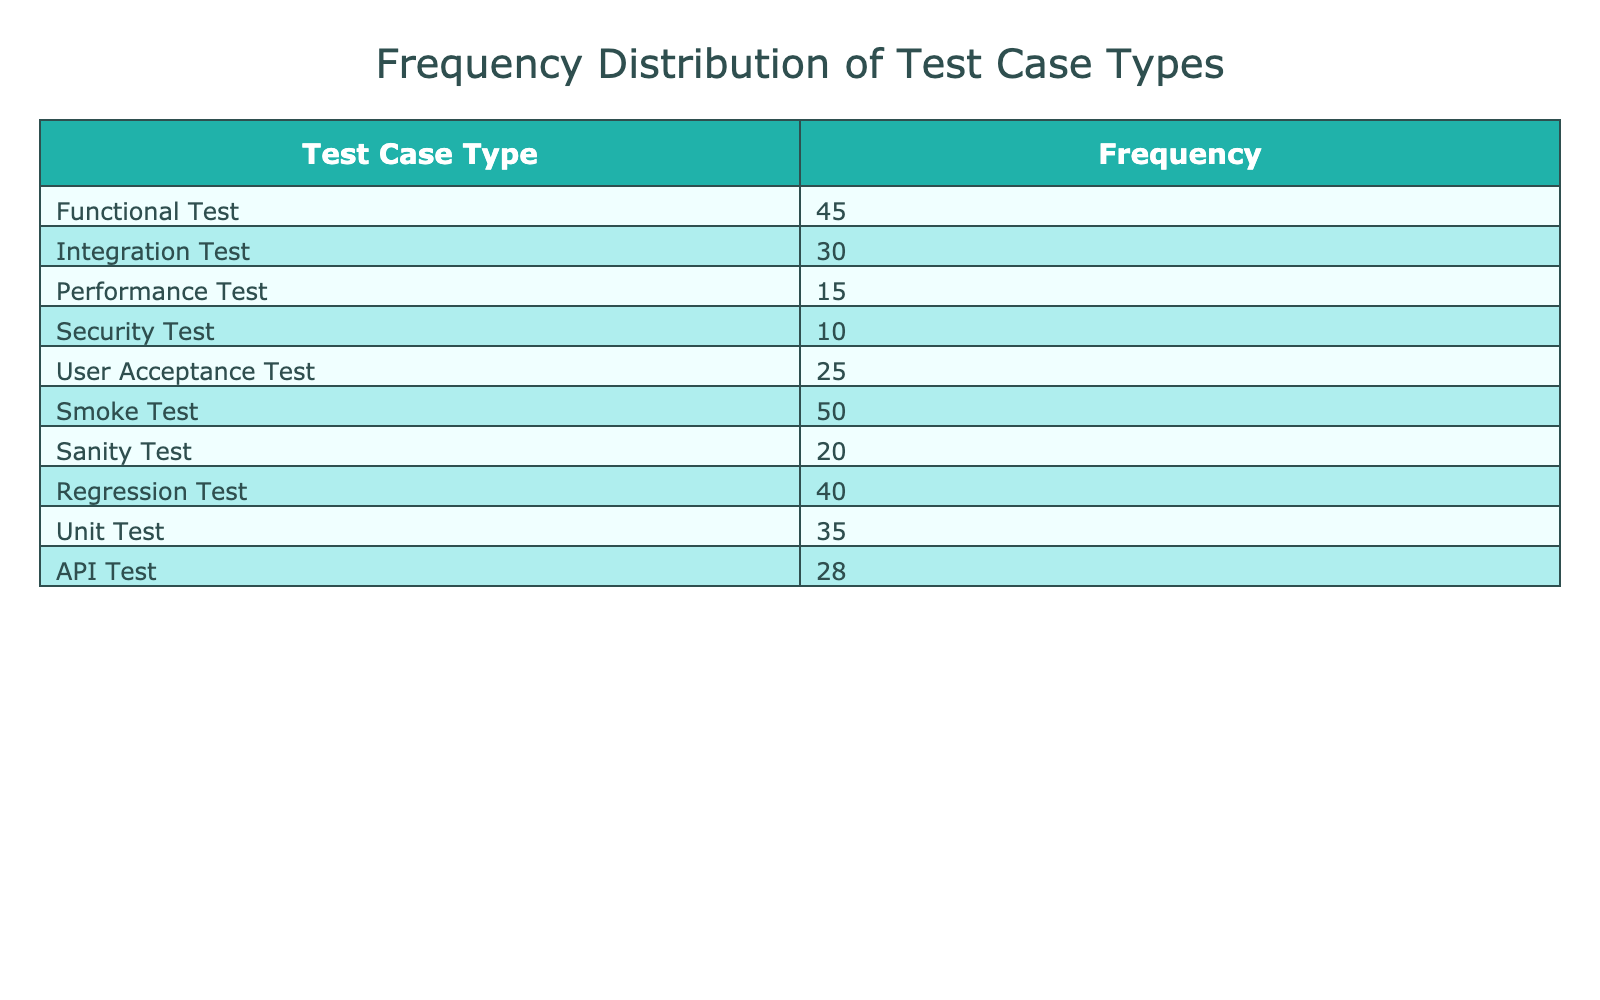What is the frequency of Smoke Test cases executed in the regression cycles? The table clearly lists the frequency of each test case type, and for Smoke Test, it indicates a frequency of 50.
Answer: 50 Which test case type has the lowest frequency? By reviewing the frequencies provided in the table, Security Test has the lowest frequency at 10.
Answer: Security Test How many test case types have a frequency greater than 30? The table shows the frequencies of each test case type. The ones with frequencies greater than 30 are: Functional Test (45), Integration Test (30), Smoke Test (50), Regression Test (40), Unit Test (35), and API Test (28). There are four test case types with frequencies greater than 30.
Answer: 4 What is the total frequency of all test case types combined? By adding the frequencies together: 45 + 30 + 15 + 10 + 25 + 50 + 20 + 40 + 35 + 28 =  353.
Answer: 353 Is it true that the frequency of API Test cases is greater than that of Performance Test cases? The table shows the frequency of API Test as 28 and Performance Test as 15. Thus, it is true that API Test has a higher frequency than Performance Test.
Answer: Yes What is the average frequency of the test case types listed in the table? To calculate the average, sum the frequencies: 353 and divide by the total number of test case types, which is 10. Thus, the average is 353 / 10 = 35.3.
Answer: 35.3 How many more frequency do Functional Tests have compared to Unit Tests? Owing to the values in the table, Functional Tests have a frequency of 45 while Unit Tests have a frequency of 35. Calculating the difference gives us: 45 - 35 = 10.
Answer: 10 Which test case types together exceed a frequency of 90? The frequencies that, when combined, exceed 90 include: Smoke Test (50) and Regression Test (40), which total to 90. However, we also have Functional Test (45) and Integration Test (30), which sum to 75, and more than one other combination such as Smoke Test + Functional Test (50 + 45 = 95). Therefore, combinations like Smoke and Regression yield more than 90.
Answer: Multiple combinations exceed 90, including Smoke Test and Regression Test 